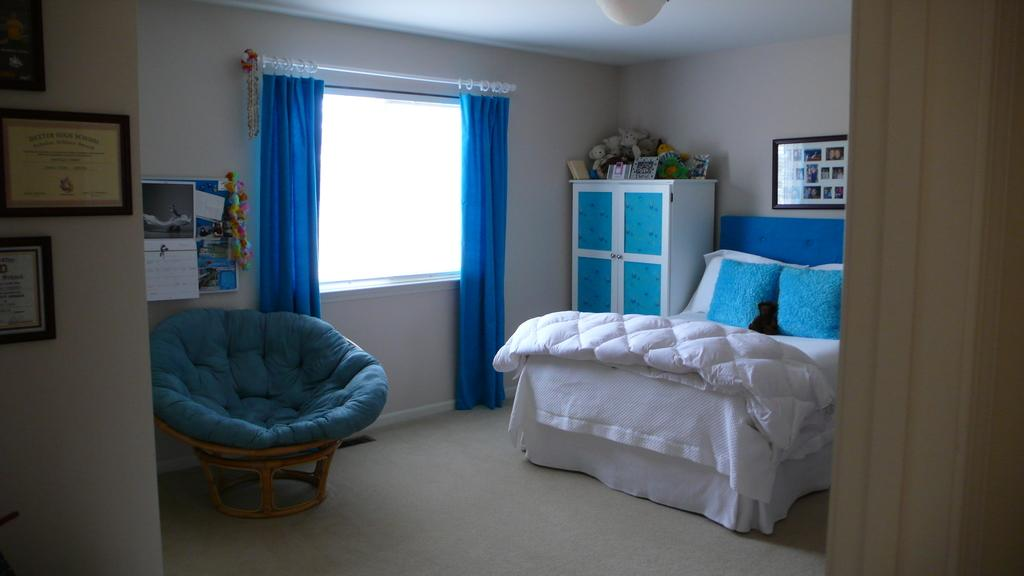What type of space is shown in the image? The image depicts a room. What furniture is present in the room? There is a bed, a chair, a cupboard, and a photo frame in the room. What architectural feature is visible in the room? There is a window in the room. What is associated with the window? There is a curtain associated with the window. What part of the room can be seen? The floor is visible in the room. What type of mitten is hanging on the curtain in the image? There is no mitten present in the image, let alone hanging on the curtain. 